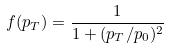<formula> <loc_0><loc_0><loc_500><loc_500>f ( p _ { T } ) = \frac { 1 } { 1 + ( p _ { T } / p _ { 0 } ) ^ { 2 } }</formula> 